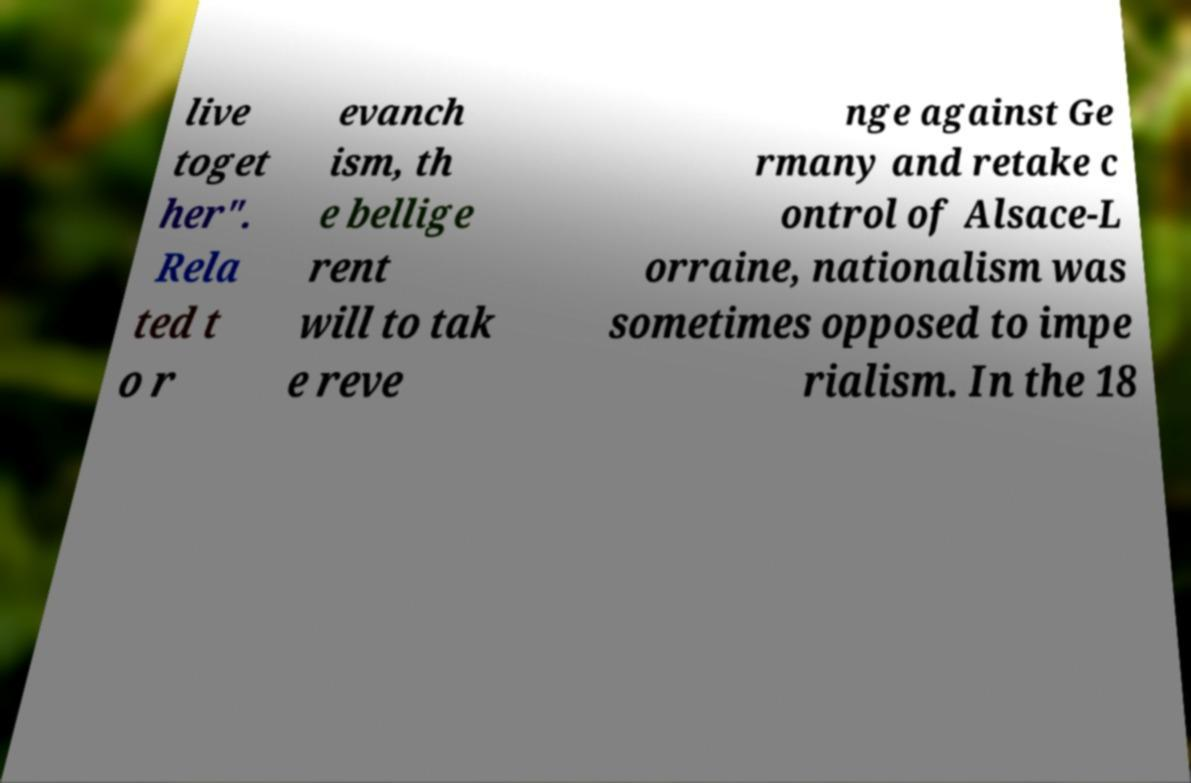Please read and relay the text visible in this image. What does it say? live toget her". Rela ted t o r evanch ism, th e bellige rent will to tak e reve nge against Ge rmany and retake c ontrol of Alsace-L orraine, nationalism was sometimes opposed to impe rialism. In the 18 